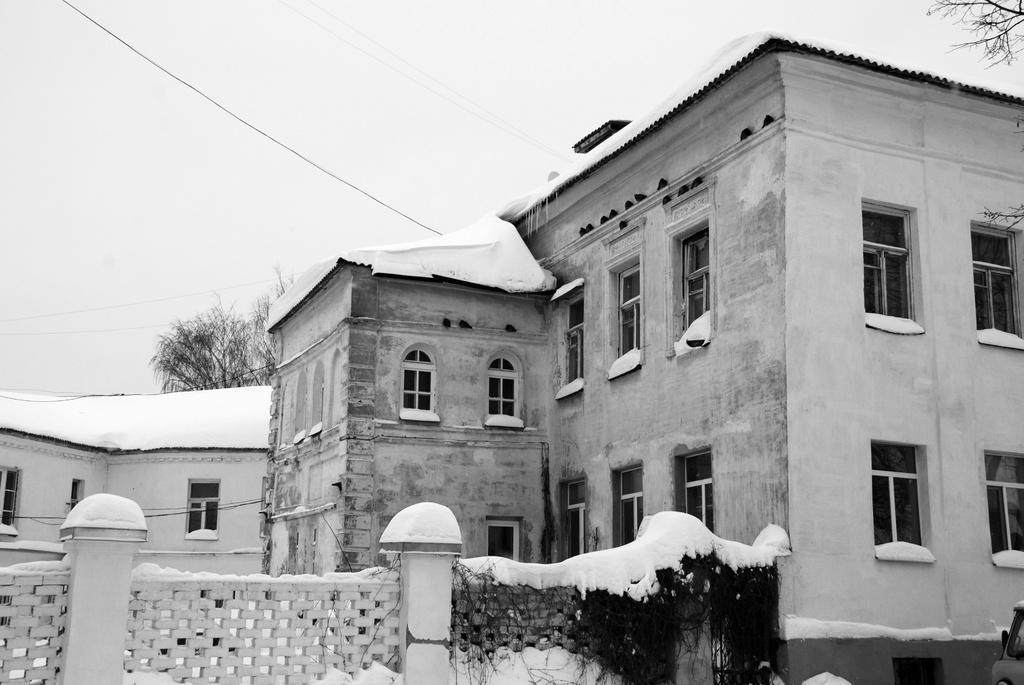In one or two sentences, can you explain what this image depicts? In this image at the bottom there are some buildings and snow, in the background there are some trees and wires. 